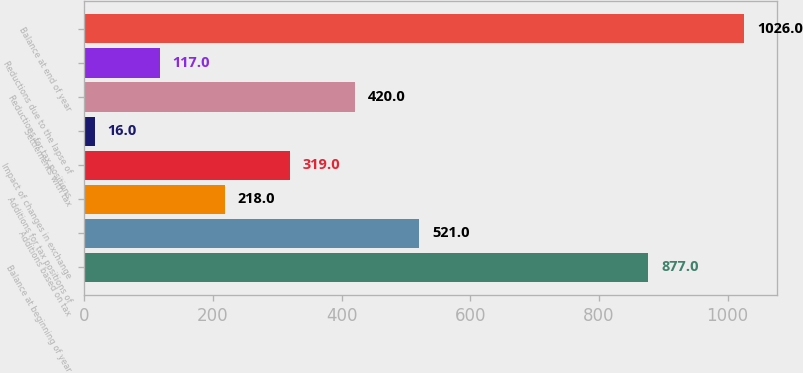Convert chart to OTSL. <chart><loc_0><loc_0><loc_500><loc_500><bar_chart><fcel>Balance at beginning of year<fcel>Additions based on tax<fcel>Additions for tax positions of<fcel>Impact of changes in exchange<fcel>Settlements with tax<fcel>Reductions for tax positions<fcel>Reductions due to the lapse of<fcel>Balance at end of year<nl><fcel>877<fcel>521<fcel>218<fcel>319<fcel>16<fcel>420<fcel>117<fcel>1026<nl></chart> 